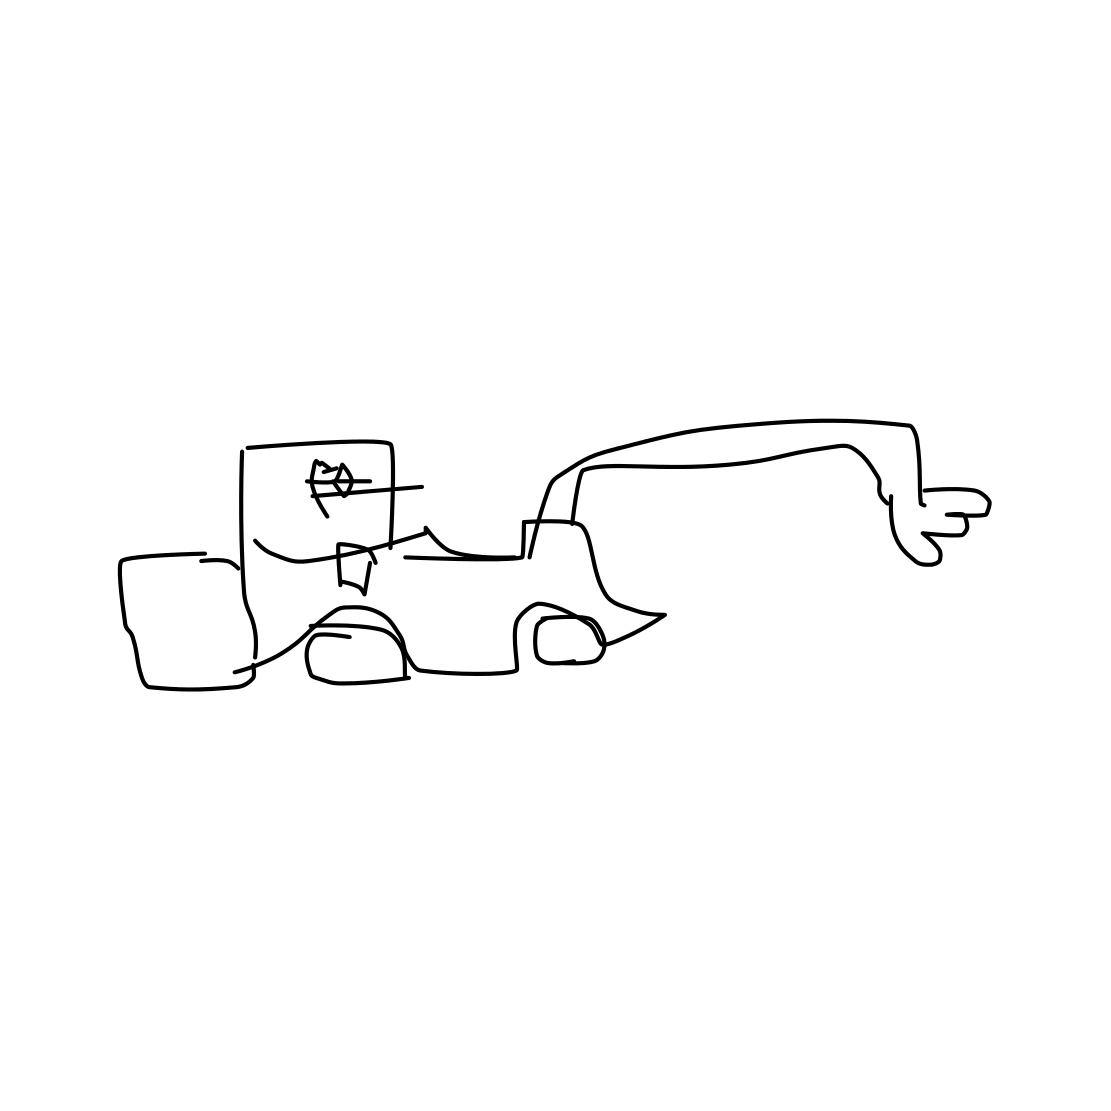What kind of vehicle is shown in the image? The image shows a basic representation of a car, identifiable by its rectangular body, wheels, and what looks like windows. 